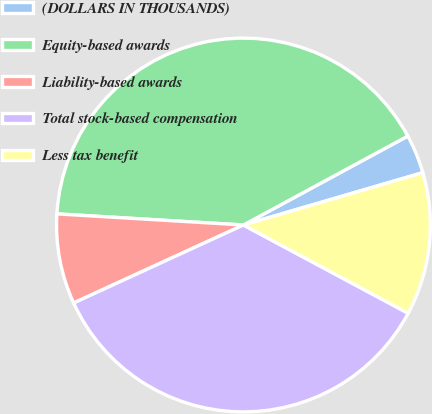Convert chart. <chart><loc_0><loc_0><loc_500><loc_500><pie_chart><fcel>(DOLLARS IN THOUSANDS)<fcel>Equity-based awards<fcel>Liability-based awards<fcel>Total stock-based compensation<fcel>Less tax benefit<nl><fcel>3.37%<fcel>41.16%<fcel>7.8%<fcel>35.32%<fcel>12.35%<nl></chart> 